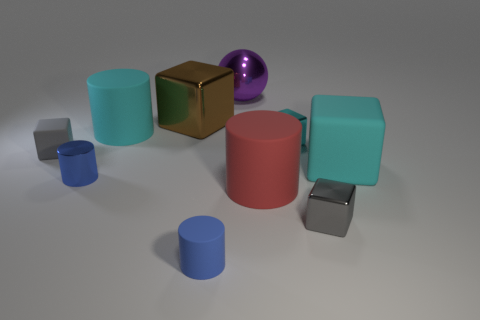Subtract all big cyan cylinders. How many cylinders are left? 3 Subtract all blue cylinders. How many cylinders are left? 2 Subtract all blue balls. How many blue cylinders are left? 2 Subtract all spheres. How many objects are left? 9 Subtract 5 cubes. How many cubes are left? 0 Subtract all gray cylinders. Subtract all red spheres. How many cylinders are left? 4 Subtract all tiny cyan metal things. Subtract all cyan blocks. How many objects are left? 7 Add 1 purple metallic objects. How many purple metallic objects are left? 2 Add 1 big matte objects. How many big matte objects exist? 4 Subtract 0 gray cylinders. How many objects are left? 10 